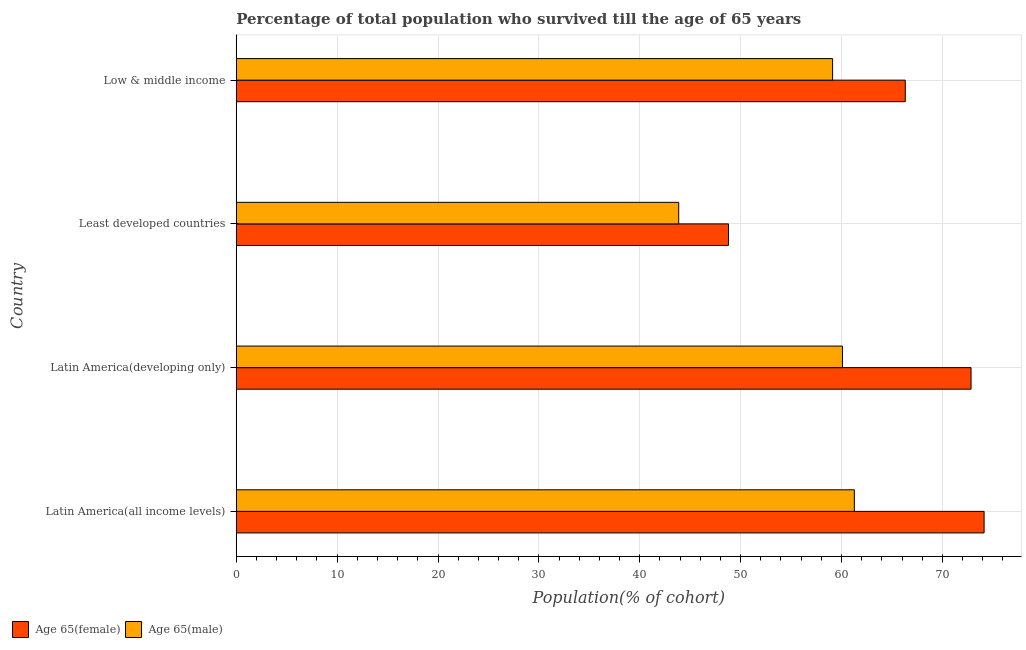How many different coloured bars are there?
Ensure brevity in your answer.  2. How many groups of bars are there?
Offer a very short reply. 4. How many bars are there on the 2nd tick from the top?
Offer a terse response. 2. What is the label of the 4th group of bars from the top?
Your answer should be compact. Latin America(all income levels). In how many cases, is the number of bars for a given country not equal to the number of legend labels?
Offer a very short reply. 0. What is the percentage of female population who survived till age of 65 in Latin America(developing only)?
Keep it short and to the point. 72.84. Across all countries, what is the maximum percentage of male population who survived till age of 65?
Keep it short and to the point. 61.27. Across all countries, what is the minimum percentage of female population who survived till age of 65?
Provide a succinct answer. 48.8. In which country was the percentage of male population who survived till age of 65 maximum?
Offer a very short reply. Latin America(all income levels). In which country was the percentage of female population who survived till age of 65 minimum?
Your answer should be very brief. Least developed countries. What is the total percentage of female population who survived till age of 65 in the graph?
Your answer should be very brief. 262.1. What is the difference between the percentage of male population who survived till age of 65 in Latin America(developing only) and that in Low & middle income?
Ensure brevity in your answer.  0.98. What is the difference between the percentage of male population who survived till age of 65 in Low & middle income and the percentage of female population who survived till age of 65 in Latin America(developing only)?
Your response must be concise. -13.73. What is the average percentage of female population who survived till age of 65 per country?
Your answer should be compact. 65.53. What is the difference between the percentage of male population who survived till age of 65 and percentage of female population who survived till age of 65 in Least developed countries?
Your answer should be compact. -4.94. In how many countries, is the percentage of male population who survived till age of 65 greater than 46 %?
Give a very brief answer. 3. What is the ratio of the percentage of female population who survived till age of 65 in Latin America(all income levels) to that in Low & middle income?
Your answer should be compact. 1.12. Is the difference between the percentage of female population who survived till age of 65 in Latin America(developing only) and Least developed countries greater than the difference between the percentage of male population who survived till age of 65 in Latin America(developing only) and Least developed countries?
Your answer should be very brief. Yes. What is the difference between the highest and the second highest percentage of male population who survived till age of 65?
Your response must be concise. 1.18. What is the difference between the highest and the lowest percentage of female population who survived till age of 65?
Offer a terse response. 25.34. Is the sum of the percentage of male population who survived till age of 65 in Least developed countries and Low & middle income greater than the maximum percentage of female population who survived till age of 65 across all countries?
Keep it short and to the point. Yes. What does the 2nd bar from the top in Latin America(all income levels) represents?
Provide a short and direct response. Age 65(female). What does the 1st bar from the bottom in Low & middle income represents?
Your response must be concise. Age 65(female). Are all the bars in the graph horizontal?
Provide a short and direct response. Yes. How many countries are there in the graph?
Your answer should be very brief. 4. What is the difference between two consecutive major ticks on the X-axis?
Provide a short and direct response. 10. Are the values on the major ticks of X-axis written in scientific E-notation?
Make the answer very short. No. Does the graph contain any zero values?
Your response must be concise. No. Where does the legend appear in the graph?
Offer a terse response. Bottom left. How many legend labels are there?
Provide a short and direct response. 2. How are the legend labels stacked?
Keep it short and to the point. Horizontal. What is the title of the graph?
Provide a succinct answer. Percentage of total population who survived till the age of 65 years. Does "IMF nonconcessional" appear as one of the legend labels in the graph?
Your answer should be very brief. No. What is the label or title of the X-axis?
Your answer should be compact. Population(% of cohort). What is the Population(% of cohort) in Age 65(female) in Latin America(all income levels)?
Offer a terse response. 74.14. What is the Population(% of cohort) in Age 65(male) in Latin America(all income levels)?
Make the answer very short. 61.27. What is the Population(% of cohort) of Age 65(female) in Latin America(developing only)?
Provide a short and direct response. 72.84. What is the Population(% of cohort) in Age 65(male) in Latin America(developing only)?
Make the answer very short. 60.09. What is the Population(% of cohort) of Age 65(female) in Least developed countries?
Offer a very short reply. 48.8. What is the Population(% of cohort) of Age 65(male) in Least developed countries?
Ensure brevity in your answer.  43.86. What is the Population(% of cohort) of Age 65(female) in Low & middle income?
Offer a terse response. 66.32. What is the Population(% of cohort) in Age 65(male) in Low & middle income?
Offer a terse response. 59.12. Across all countries, what is the maximum Population(% of cohort) in Age 65(female)?
Make the answer very short. 74.14. Across all countries, what is the maximum Population(% of cohort) in Age 65(male)?
Your response must be concise. 61.27. Across all countries, what is the minimum Population(% of cohort) of Age 65(female)?
Offer a very short reply. 48.8. Across all countries, what is the minimum Population(% of cohort) of Age 65(male)?
Give a very brief answer. 43.86. What is the total Population(% of cohort) in Age 65(female) in the graph?
Offer a terse response. 262.1. What is the total Population(% of cohort) of Age 65(male) in the graph?
Your response must be concise. 224.35. What is the difference between the Population(% of cohort) in Age 65(female) in Latin America(all income levels) and that in Latin America(developing only)?
Provide a succinct answer. 1.29. What is the difference between the Population(% of cohort) in Age 65(male) in Latin America(all income levels) and that in Latin America(developing only)?
Your answer should be compact. 1.18. What is the difference between the Population(% of cohort) in Age 65(female) in Latin America(all income levels) and that in Least developed countries?
Offer a very short reply. 25.34. What is the difference between the Population(% of cohort) of Age 65(male) in Latin America(all income levels) and that in Least developed countries?
Give a very brief answer. 17.41. What is the difference between the Population(% of cohort) in Age 65(female) in Latin America(all income levels) and that in Low & middle income?
Offer a very short reply. 7.81. What is the difference between the Population(% of cohort) in Age 65(male) in Latin America(all income levels) and that in Low & middle income?
Provide a short and direct response. 2.16. What is the difference between the Population(% of cohort) of Age 65(female) in Latin America(developing only) and that in Least developed countries?
Offer a terse response. 24.04. What is the difference between the Population(% of cohort) of Age 65(male) in Latin America(developing only) and that in Least developed countries?
Your answer should be very brief. 16.23. What is the difference between the Population(% of cohort) in Age 65(female) in Latin America(developing only) and that in Low & middle income?
Your answer should be very brief. 6.52. What is the difference between the Population(% of cohort) in Age 65(male) in Latin America(developing only) and that in Low & middle income?
Your answer should be very brief. 0.98. What is the difference between the Population(% of cohort) in Age 65(female) in Least developed countries and that in Low & middle income?
Keep it short and to the point. -17.52. What is the difference between the Population(% of cohort) of Age 65(male) in Least developed countries and that in Low & middle income?
Provide a short and direct response. -15.25. What is the difference between the Population(% of cohort) of Age 65(female) in Latin America(all income levels) and the Population(% of cohort) of Age 65(male) in Latin America(developing only)?
Provide a short and direct response. 14.04. What is the difference between the Population(% of cohort) of Age 65(female) in Latin America(all income levels) and the Population(% of cohort) of Age 65(male) in Least developed countries?
Give a very brief answer. 30.27. What is the difference between the Population(% of cohort) in Age 65(female) in Latin America(all income levels) and the Population(% of cohort) in Age 65(male) in Low & middle income?
Provide a succinct answer. 15.02. What is the difference between the Population(% of cohort) of Age 65(female) in Latin America(developing only) and the Population(% of cohort) of Age 65(male) in Least developed countries?
Provide a succinct answer. 28.98. What is the difference between the Population(% of cohort) of Age 65(female) in Latin America(developing only) and the Population(% of cohort) of Age 65(male) in Low & middle income?
Your response must be concise. 13.73. What is the difference between the Population(% of cohort) of Age 65(female) in Least developed countries and the Population(% of cohort) of Age 65(male) in Low & middle income?
Provide a succinct answer. -10.32. What is the average Population(% of cohort) in Age 65(female) per country?
Your response must be concise. 65.53. What is the average Population(% of cohort) of Age 65(male) per country?
Provide a short and direct response. 56.09. What is the difference between the Population(% of cohort) of Age 65(female) and Population(% of cohort) of Age 65(male) in Latin America(all income levels)?
Give a very brief answer. 12.86. What is the difference between the Population(% of cohort) in Age 65(female) and Population(% of cohort) in Age 65(male) in Latin America(developing only)?
Offer a terse response. 12.75. What is the difference between the Population(% of cohort) of Age 65(female) and Population(% of cohort) of Age 65(male) in Least developed countries?
Your answer should be compact. 4.94. What is the difference between the Population(% of cohort) in Age 65(female) and Population(% of cohort) in Age 65(male) in Low & middle income?
Give a very brief answer. 7.21. What is the ratio of the Population(% of cohort) of Age 65(female) in Latin America(all income levels) to that in Latin America(developing only)?
Your answer should be compact. 1.02. What is the ratio of the Population(% of cohort) in Age 65(male) in Latin America(all income levels) to that in Latin America(developing only)?
Your answer should be very brief. 1.02. What is the ratio of the Population(% of cohort) in Age 65(female) in Latin America(all income levels) to that in Least developed countries?
Your response must be concise. 1.52. What is the ratio of the Population(% of cohort) of Age 65(male) in Latin America(all income levels) to that in Least developed countries?
Ensure brevity in your answer.  1.4. What is the ratio of the Population(% of cohort) of Age 65(female) in Latin America(all income levels) to that in Low & middle income?
Keep it short and to the point. 1.12. What is the ratio of the Population(% of cohort) of Age 65(male) in Latin America(all income levels) to that in Low & middle income?
Keep it short and to the point. 1.04. What is the ratio of the Population(% of cohort) in Age 65(female) in Latin America(developing only) to that in Least developed countries?
Your answer should be compact. 1.49. What is the ratio of the Population(% of cohort) of Age 65(male) in Latin America(developing only) to that in Least developed countries?
Your response must be concise. 1.37. What is the ratio of the Population(% of cohort) in Age 65(female) in Latin America(developing only) to that in Low & middle income?
Offer a very short reply. 1.1. What is the ratio of the Population(% of cohort) in Age 65(male) in Latin America(developing only) to that in Low & middle income?
Your answer should be very brief. 1.02. What is the ratio of the Population(% of cohort) of Age 65(female) in Least developed countries to that in Low & middle income?
Your answer should be very brief. 0.74. What is the ratio of the Population(% of cohort) of Age 65(male) in Least developed countries to that in Low & middle income?
Give a very brief answer. 0.74. What is the difference between the highest and the second highest Population(% of cohort) in Age 65(female)?
Your answer should be very brief. 1.29. What is the difference between the highest and the second highest Population(% of cohort) in Age 65(male)?
Your answer should be very brief. 1.18. What is the difference between the highest and the lowest Population(% of cohort) in Age 65(female)?
Provide a succinct answer. 25.34. What is the difference between the highest and the lowest Population(% of cohort) of Age 65(male)?
Make the answer very short. 17.41. 